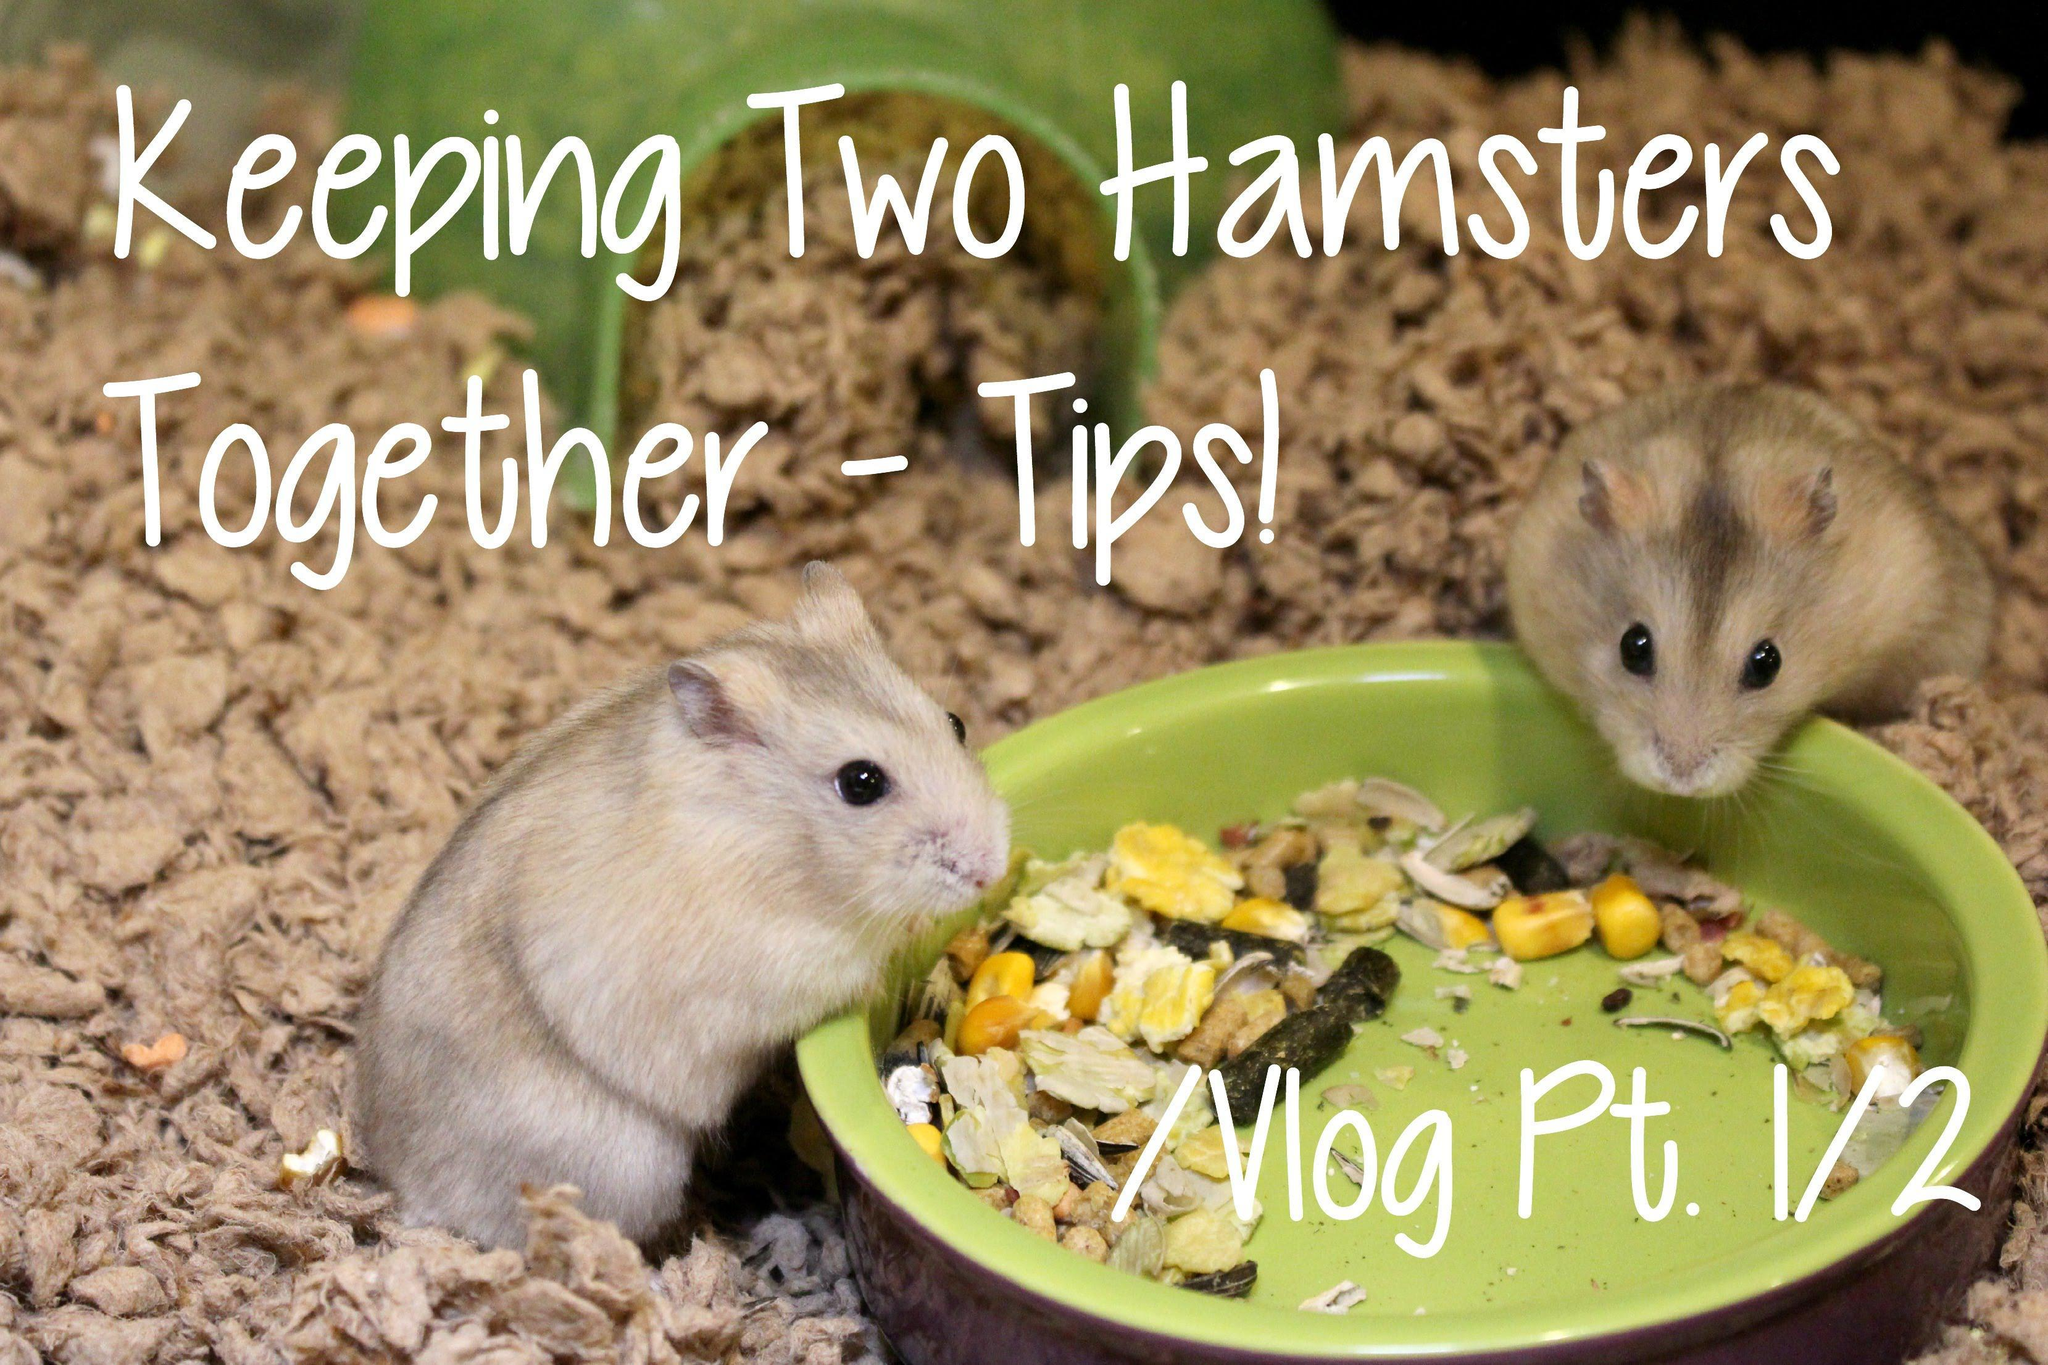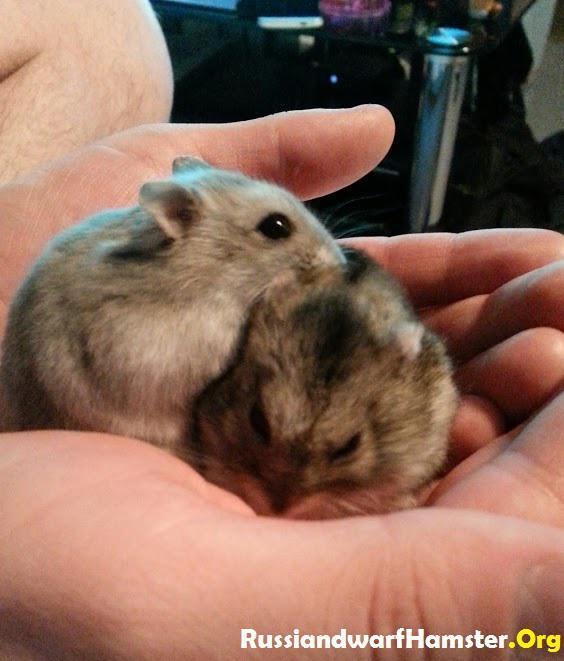The first image is the image on the left, the second image is the image on the right. Given the left and right images, does the statement "In both images, two hamsters are touching each other." hold true? Answer yes or no. No. The first image is the image on the left, the second image is the image on the right. Considering the images on both sides, is "A human finger is in an image with no more than two hamsters." valid? Answer yes or no. Yes. 